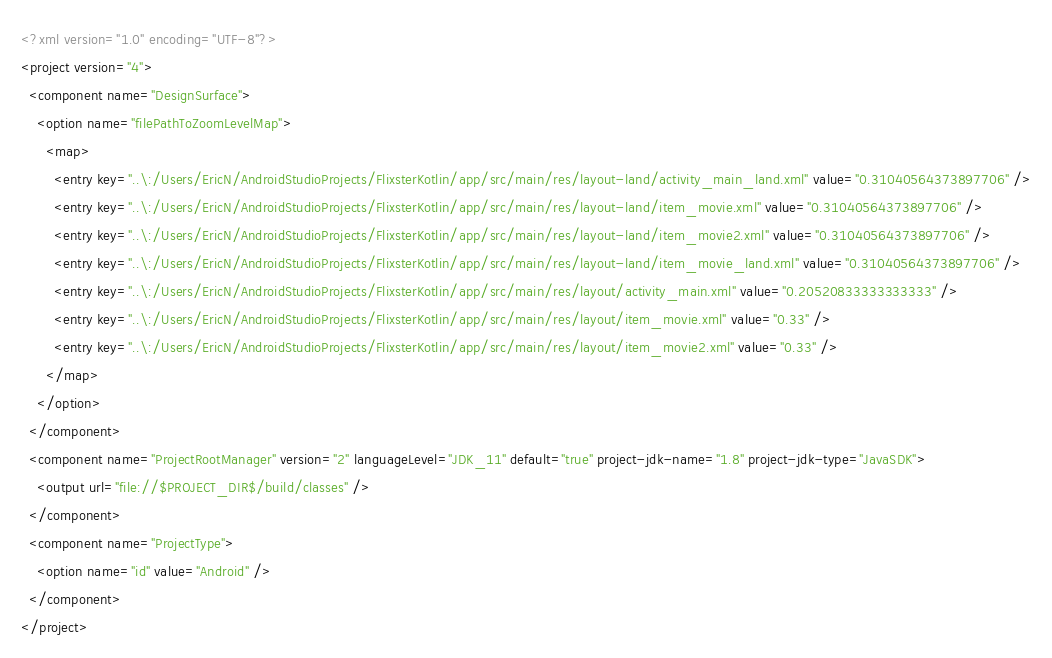<code> <loc_0><loc_0><loc_500><loc_500><_XML_><?xml version="1.0" encoding="UTF-8"?>
<project version="4">
  <component name="DesignSurface">
    <option name="filePathToZoomLevelMap">
      <map>
        <entry key="..\:/Users/EricN/AndroidStudioProjects/FlixsterKotlin/app/src/main/res/layout-land/activity_main_land.xml" value="0.31040564373897706" />
        <entry key="..\:/Users/EricN/AndroidStudioProjects/FlixsterKotlin/app/src/main/res/layout-land/item_movie.xml" value="0.31040564373897706" />
        <entry key="..\:/Users/EricN/AndroidStudioProjects/FlixsterKotlin/app/src/main/res/layout-land/item_movie2.xml" value="0.31040564373897706" />
        <entry key="..\:/Users/EricN/AndroidStudioProjects/FlixsterKotlin/app/src/main/res/layout-land/item_movie_land.xml" value="0.31040564373897706" />
        <entry key="..\:/Users/EricN/AndroidStudioProjects/FlixsterKotlin/app/src/main/res/layout/activity_main.xml" value="0.20520833333333333" />
        <entry key="..\:/Users/EricN/AndroidStudioProjects/FlixsterKotlin/app/src/main/res/layout/item_movie.xml" value="0.33" />
        <entry key="..\:/Users/EricN/AndroidStudioProjects/FlixsterKotlin/app/src/main/res/layout/item_movie2.xml" value="0.33" />
      </map>
    </option>
  </component>
  <component name="ProjectRootManager" version="2" languageLevel="JDK_11" default="true" project-jdk-name="1.8" project-jdk-type="JavaSDK">
    <output url="file://$PROJECT_DIR$/build/classes" />
  </component>
  <component name="ProjectType">
    <option name="id" value="Android" />
  </component>
</project></code> 